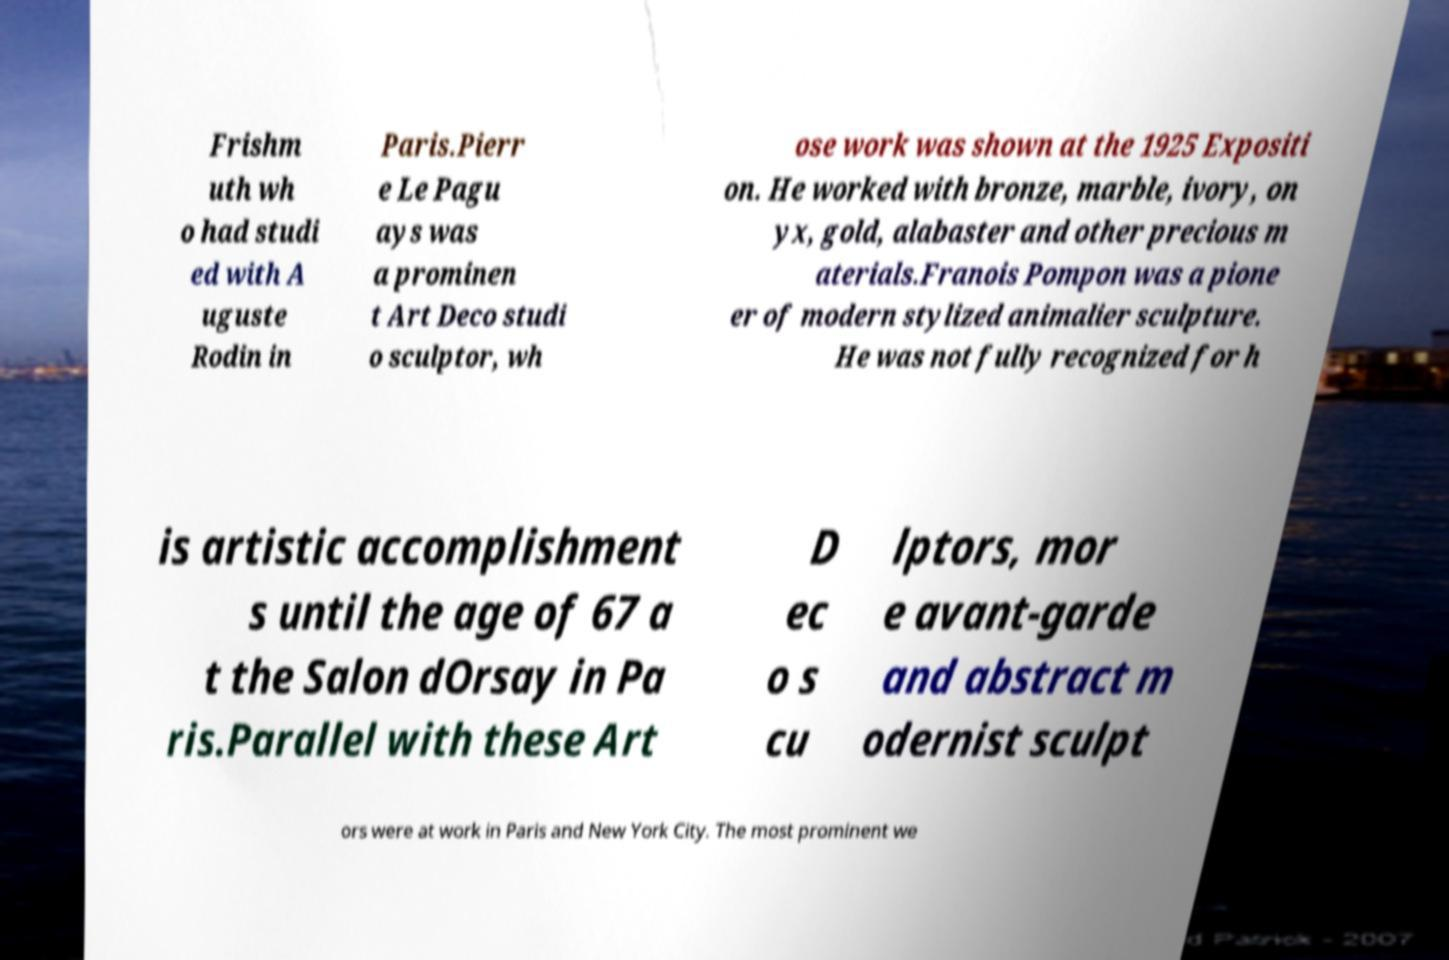Can you accurately transcribe the text from the provided image for me? Frishm uth wh o had studi ed with A uguste Rodin in Paris.Pierr e Le Pagu ays was a prominen t Art Deco studi o sculptor, wh ose work was shown at the 1925 Expositi on. He worked with bronze, marble, ivory, on yx, gold, alabaster and other precious m aterials.Franois Pompon was a pione er of modern stylized animalier sculpture. He was not fully recognized for h is artistic accomplishment s until the age of 67 a t the Salon dOrsay in Pa ris.Parallel with these Art D ec o s cu lptors, mor e avant-garde and abstract m odernist sculpt ors were at work in Paris and New York City. The most prominent we 